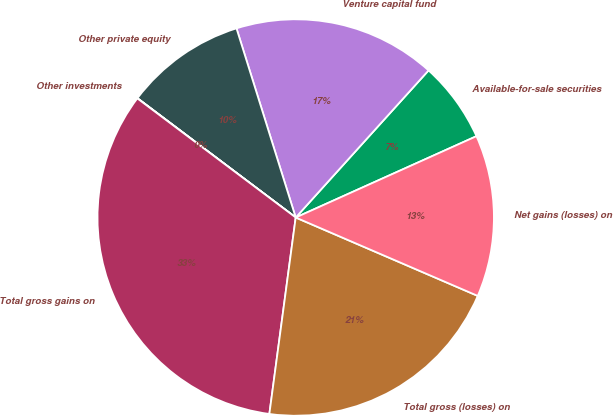Convert chart. <chart><loc_0><loc_0><loc_500><loc_500><pie_chart><fcel>Available-for-sale securities<fcel>Venture capital fund<fcel>Other private equity<fcel>Other investments<fcel>Total gross gains on<fcel>Total gross (losses) on<fcel>Net gains (losses) on<nl><fcel>6.58%<fcel>16.52%<fcel>9.89%<fcel>0.02%<fcel>33.14%<fcel>20.65%<fcel>13.2%<nl></chart> 